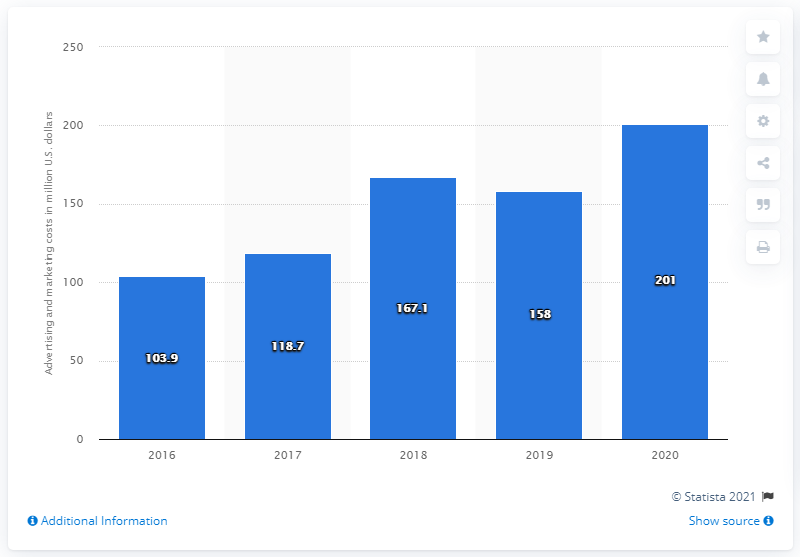List a handful of essential elements in this visual. Capri Holdings spent a significant amount on advertising and marketing in 2020 and 201.. 